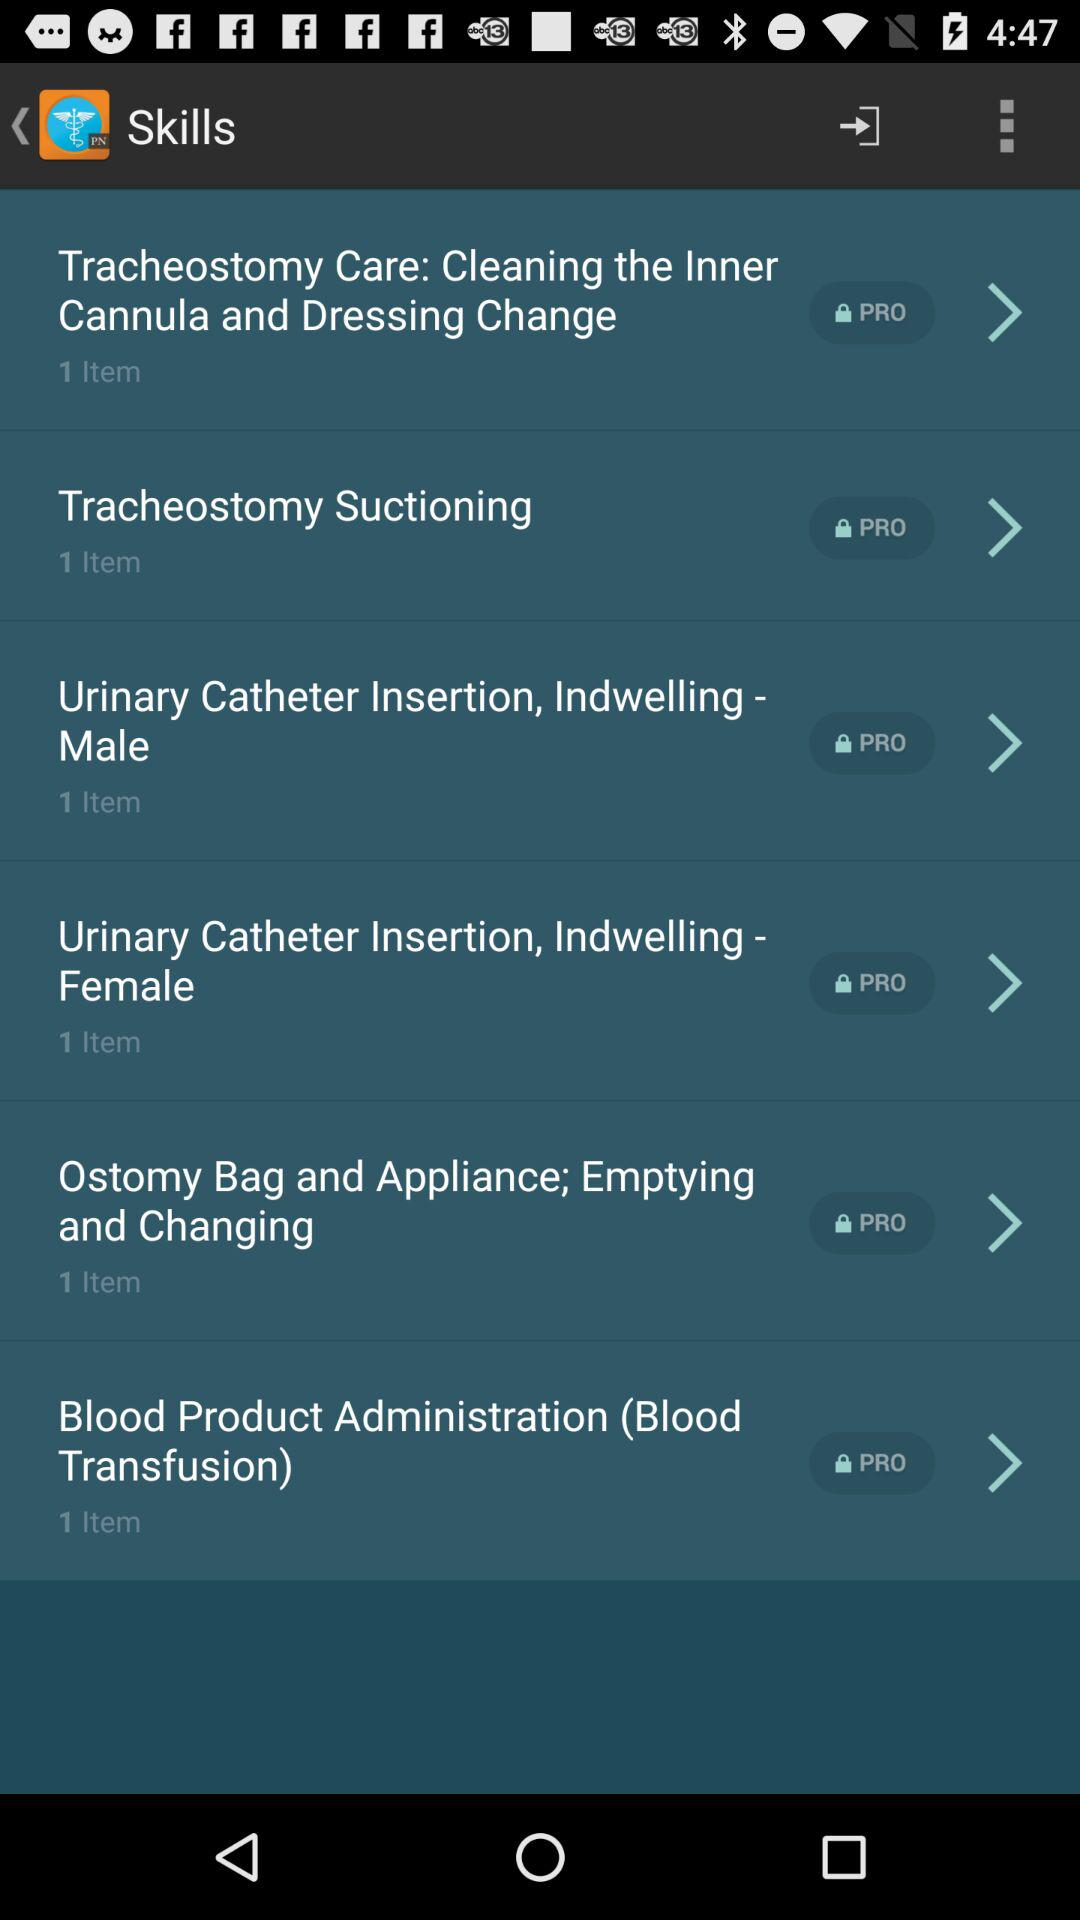Which upgrade version is used for tracheostomy suctioning?
When the provided information is insufficient, respond with <no answer>. <no answer> 